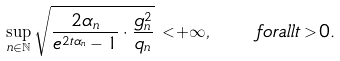<formula> <loc_0><loc_0><loc_500><loc_500>\sup _ { n \in \mathbb { N } } \sqrt { \frac { 2 \alpha _ { n } } { e ^ { 2 t \alpha _ { n } } - 1 } \cdot \frac { g _ { n } ^ { 2 } } { q _ { n } } } \, < + \infty , \quad f o r a l l t > 0 .</formula> 